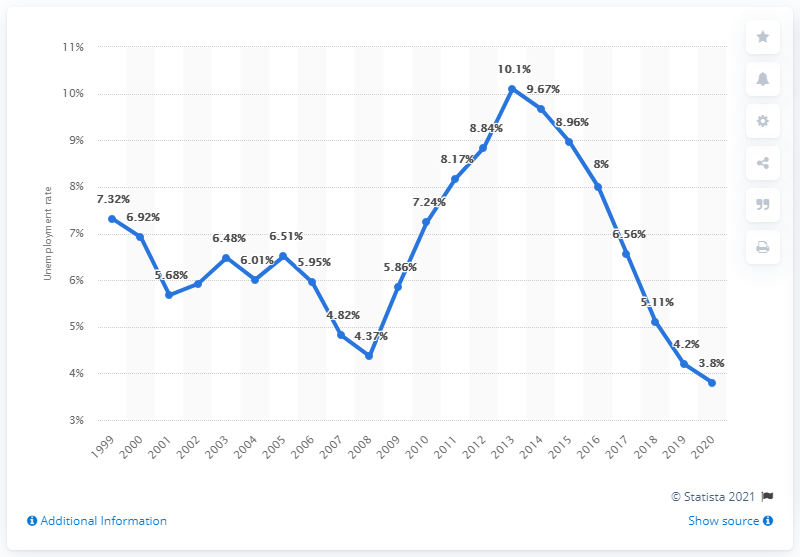Identify some key points in this picture. The unemployment rate in Slovenia in 2020 was 3.8%. 